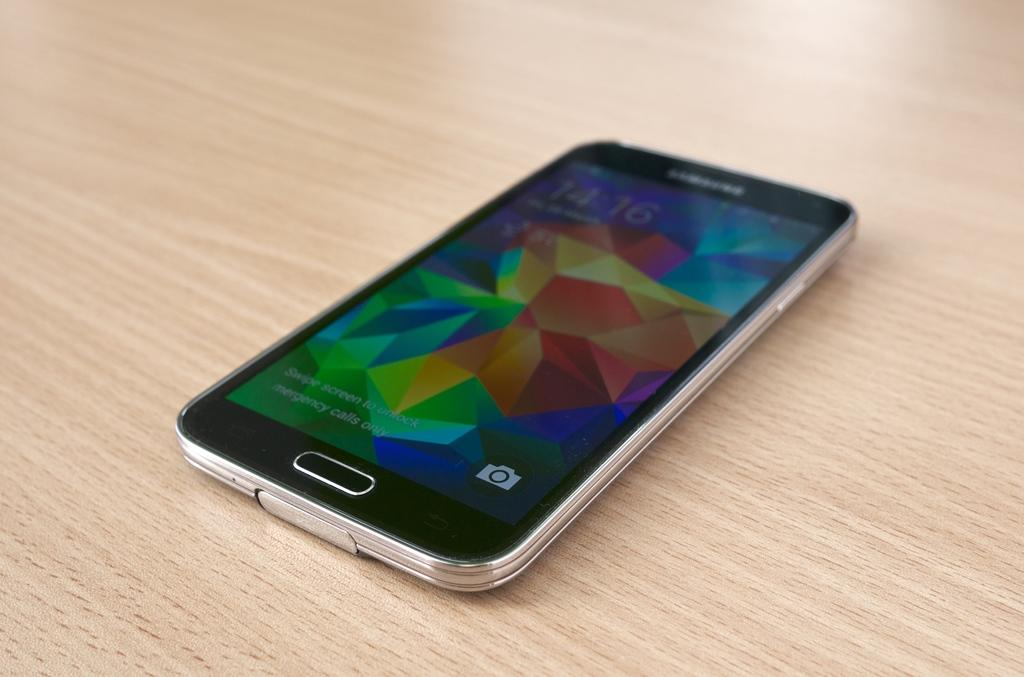<image>
Summarize the visual content of the image. A phone on a table with the screen on and it says Emergency Calls Only on the bottom of the screen. 